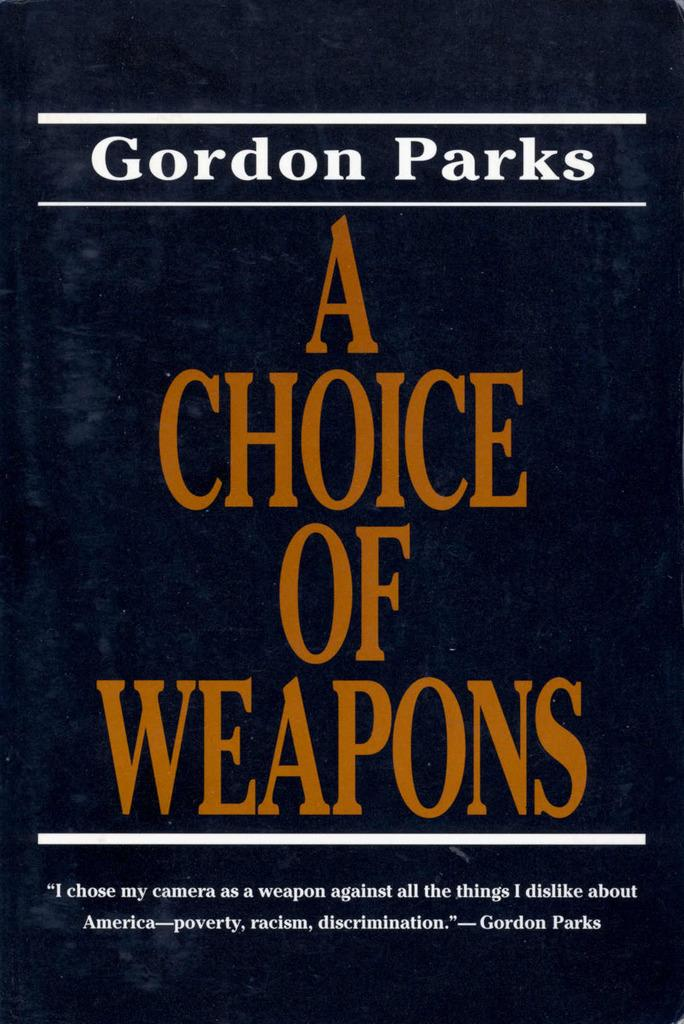Provide a one-sentence caption for the provided image. The book shown is written by the author Gordon Parks. 